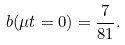Convert formula to latex. <formula><loc_0><loc_0><loc_500><loc_500>b ( \mu t = 0 ) = \frac { 7 } { 8 1 } .</formula> 